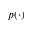<formula> <loc_0><loc_0><loc_500><loc_500>p ( \cdot )</formula> 